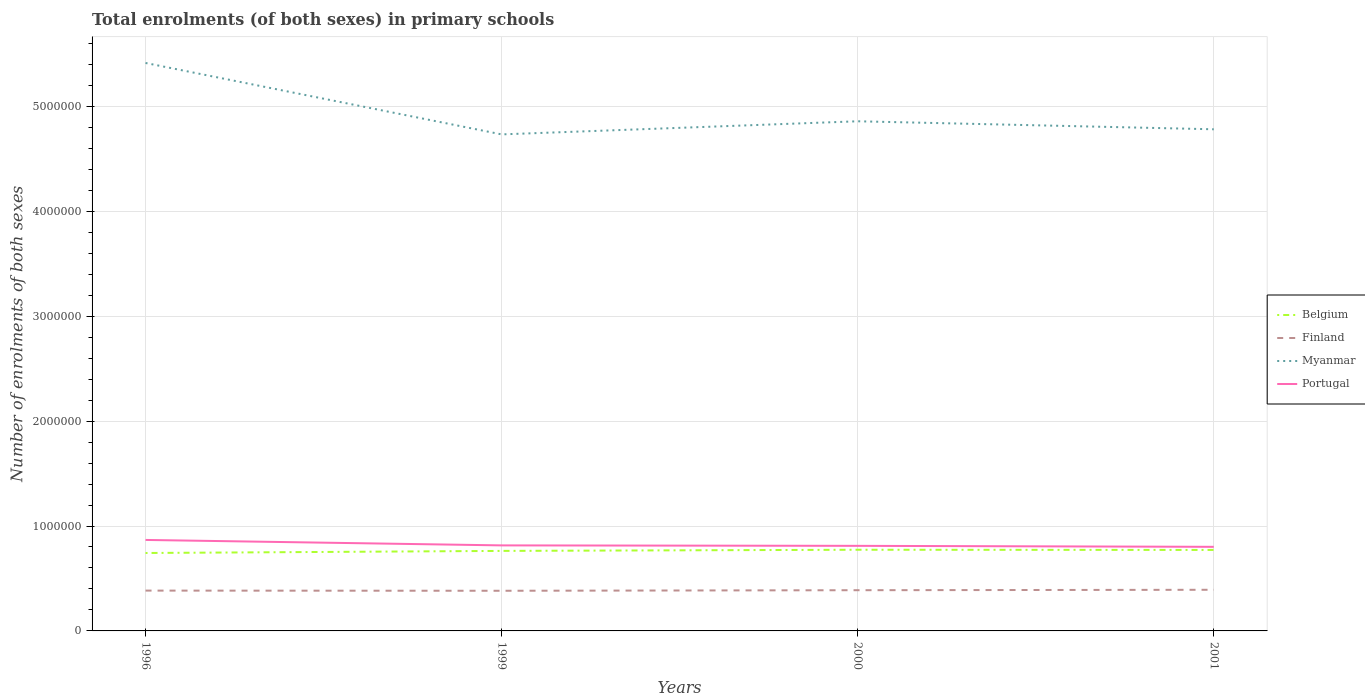How many different coloured lines are there?
Provide a short and direct response. 4. Does the line corresponding to Myanmar intersect with the line corresponding to Finland?
Your answer should be compact. No. Across all years, what is the maximum number of enrolments in primary schools in Portugal?
Ensure brevity in your answer.  8.02e+05. In which year was the number of enrolments in primary schools in Myanmar maximum?
Ensure brevity in your answer.  1999. What is the total number of enrolments in primary schools in Myanmar in the graph?
Give a very brief answer. 6.32e+05. What is the difference between the highest and the second highest number of enrolments in primary schools in Portugal?
Make the answer very short. 6.57e+04. What is the difference between the highest and the lowest number of enrolments in primary schools in Myanmar?
Keep it short and to the point. 1. Is the number of enrolments in primary schools in Finland strictly greater than the number of enrolments in primary schools in Belgium over the years?
Your answer should be very brief. Yes. How many lines are there?
Your answer should be very brief. 4. How many years are there in the graph?
Ensure brevity in your answer.  4. What is the difference between two consecutive major ticks on the Y-axis?
Your answer should be very brief. 1.00e+06. How many legend labels are there?
Your answer should be compact. 4. What is the title of the graph?
Your response must be concise. Total enrolments (of both sexes) in primary schools. Does "Bermuda" appear as one of the legend labels in the graph?
Your answer should be very brief. No. What is the label or title of the X-axis?
Keep it short and to the point. Years. What is the label or title of the Y-axis?
Provide a succinct answer. Number of enrolments of both sexes. What is the Number of enrolments of both sexes in Belgium in 1996?
Provide a short and direct response. 7.43e+05. What is the Number of enrolments of both sexes of Finland in 1996?
Offer a terse response. 3.84e+05. What is the Number of enrolments of both sexes of Myanmar in 1996?
Your response must be concise. 5.41e+06. What is the Number of enrolments of both sexes of Portugal in 1996?
Offer a terse response. 8.67e+05. What is the Number of enrolments of both sexes in Belgium in 1999?
Your answer should be very brief. 7.63e+05. What is the Number of enrolments of both sexes in Finland in 1999?
Ensure brevity in your answer.  3.83e+05. What is the Number of enrolments of both sexes of Myanmar in 1999?
Your response must be concise. 4.73e+06. What is the Number of enrolments of both sexes of Portugal in 1999?
Provide a succinct answer. 8.15e+05. What is the Number of enrolments of both sexes of Belgium in 2000?
Make the answer very short. 7.74e+05. What is the Number of enrolments of both sexes of Finland in 2000?
Your response must be concise. 3.88e+05. What is the Number of enrolments of both sexes in Myanmar in 2000?
Offer a terse response. 4.86e+06. What is the Number of enrolments of both sexes in Portugal in 2000?
Ensure brevity in your answer.  8.11e+05. What is the Number of enrolments of both sexes in Belgium in 2001?
Provide a short and direct response. 7.72e+05. What is the Number of enrolments of both sexes in Finland in 2001?
Offer a terse response. 3.92e+05. What is the Number of enrolments of both sexes of Myanmar in 2001?
Your response must be concise. 4.78e+06. What is the Number of enrolments of both sexes in Portugal in 2001?
Your answer should be very brief. 8.02e+05. Across all years, what is the maximum Number of enrolments of both sexes of Belgium?
Keep it short and to the point. 7.74e+05. Across all years, what is the maximum Number of enrolments of both sexes of Finland?
Provide a succinct answer. 3.92e+05. Across all years, what is the maximum Number of enrolments of both sexes of Myanmar?
Provide a short and direct response. 5.41e+06. Across all years, what is the maximum Number of enrolments of both sexes of Portugal?
Offer a terse response. 8.67e+05. Across all years, what is the minimum Number of enrolments of both sexes in Belgium?
Your answer should be very brief. 7.43e+05. Across all years, what is the minimum Number of enrolments of both sexes in Finland?
Your response must be concise. 3.83e+05. Across all years, what is the minimum Number of enrolments of both sexes of Myanmar?
Give a very brief answer. 4.73e+06. Across all years, what is the minimum Number of enrolments of both sexes in Portugal?
Your answer should be compact. 8.02e+05. What is the total Number of enrolments of both sexes of Belgium in the graph?
Your answer should be compact. 3.05e+06. What is the total Number of enrolments of both sexes in Finland in the graph?
Provide a succinct answer. 1.55e+06. What is the total Number of enrolments of both sexes of Myanmar in the graph?
Keep it short and to the point. 1.98e+07. What is the total Number of enrolments of both sexes of Portugal in the graph?
Make the answer very short. 3.30e+06. What is the difference between the Number of enrolments of both sexes of Belgium in 1996 and that in 1999?
Your response must be concise. -1.99e+04. What is the difference between the Number of enrolments of both sexes of Finland in 1996 and that in 1999?
Provide a short and direct response. 1623. What is the difference between the Number of enrolments of both sexes in Myanmar in 1996 and that in 1999?
Offer a very short reply. 6.81e+05. What is the difference between the Number of enrolments of both sexes in Portugal in 1996 and that in 1999?
Provide a succinct answer. 5.20e+04. What is the difference between the Number of enrolments of both sexes in Belgium in 1996 and that in 2000?
Your response must be concise. -3.09e+04. What is the difference between the Number of enrolments of both sexes of Finland in 1996 and that in 2000?
Provide a succinct answer. -3694. What is the difference between the Number of enrolments of both sexes in Myanmar in 1996 and that in 2000?
Keep it short and to the point. 5.56e+05. What is the difference between the Number of enrolments of both sexes in Portugal in 1996 and that in 2000?
Offer a terse response. 5.63e+04. What is the difference between the Number of enrolments of both sexes in Belgium in 1996 and that in 2001?
Offer a very short reply. -2.91e+04. What is the difference between the Number of enrolments of both sexes of Finland in 1996 and that in 2001?
Your answer should be compact. -7781. What is the difference between the Number of enrolments of both sexes in Myanmar in 1996 and that in 2001?
Ensure brevity in your answer.  6.32e+05. What is the difference between the Number of enrolments of both sexes in Portugal in 1996 and that in 2001?
Provide a succinct answer. 6.57e+04. What is the difference between the Number of enrolments of both sexes in Belgium in 1999 and that in 2000?
Offer a terse response. -1.10e+04. What is the difference between the Number of enrolments of both sexes in Finland in 1999 and that in 2000?
Your answer should be very brief. -5317. What is the difference between the Number of enrolments of both sexes in Myanmar in 1999 and that in 2000?
Offer a terse response. -1.25e+05. What is the difference between the Number of enrolments of both sexes in Portugal in 1999 and that in 2000?
Provide a short and direct response. 4235. What is the difference between the Number of enrolments of both sexes of Belgium in 1999 and that in 2001?
Offer a very short reply. -9155. What is the difference between the Number of enrolments of both sexes in Finland in 1999 and that in 2001?
Your answer should be compact. -9404. What is the difference between the Number of enrolments of both sexes of Myanmar in 1999 and that in 2001?
Offer a terse response. -4.86e+04. What is the difference between the Number of enrolments of both sexes in Portugal in 1999 and that in 2001?
Your answer should be very brief. 1.37e+04. What is the difference between the Number of enrolments of both sexes in Belgium in 2000 and that in 2001?
Provide a short and direct response. 1853. What is the difference between the Number of enrolments of both sexes of Finland in 2000 and that in 2001?
Your response must be concise. -4087. What is the difference between the Number of enrolments of both sexes in Myanmar in 2000 and that in 2001?
Keep it short and to the point. 7.64e+04. What is the difference between the Number of enrolments of both sexes in Portugal in 2000 and that in 2001?
Your response must be concise. 9451. What is the difference between the Number of enrolments of both sexes in Belgium in 1996 and the Number of enrolments of both sexes in Finland in 1999?
Keep it short and to the point. 3.60e+05. What is the difference between the Number of enrolments of both sexes in Belgium in 1996 and the Number of enrolments of both sexes in Myanmar in 1999?
Offer a terse response. -3.99e+06. What is the difference between the Number of enrolments of both sexes in Belgium in 1996 and the Number of enrolments of both sexes in Portugal in 1999?
Offer a terse response. -7.24e+04. What is the difference between the Number of enrolments of both sexes in Finland in 1996 and the Number of enrolments of both sexes in Myanmar in 1999?
Give a very brief answer. -4.35e+06. What is the difference between the Number of enrolments of both sexes in Finland in 1996 and the Number of enrolments of both sexes in Portugal in 1999?
Give a very brief answer. -4.31e+05. What is the difference between the Number of enrolments of both sexes in Myanmar in 1996 and the Number of enrolments of both sexes in Portugal in 1999?
Make the answer very short. 4.60e+06. What is the difference between the Number of enrolments of both sexes in Belgium in 1996 and the Number of enrolments of both sexes in Finland in 2000?
Provide a succinct answer. 3.55e+05. What is the difference between the Number of enrolments of both sexes of Belgium in 1996 and the Number of enrolments of both sexes of Myanmar in 2000?
Your answer should be compact. -4.12e+06. What is the difference between the Number of enrolments of both sexes in Belgium in 1996 and the Number of enrolments of both sexes in Portugal in 2000?
Your response must be concise. -6.82e+04. What is the difference between the Number of enrolments of both sexes in Finland in 1996 and the Number of enrolments of both sexes in Myanmar in 2000?
Ensure brevity in your answer.  -4.47e+06. What is the difference between the Number of enrolments of both sexes of Finland in 1996 and the Number of enrolments of both sexes of Portugal in 2000?
Give a very brief answer. -4.27e+05. What is the difference between the Number of enrolments of both sexes of Myanmar in 1996 and the Number of enrolments of both sexes of Portugal in 2000?
Ensure brevity in your answer.  4.60e+06. What is the difference between the Number of enrolments of both sexes of Belgium in 1996 and the Number of enrolments of both sexes of Finland in 2001?
Ensure brevity in your answer.  3.51e+05. What is the difference between the Number of enrolments of both sexes of Belgium in 1996 and the Number of enrolments of both sexes of Myanmar in 2001?
Keep it short and to the point. -4.04e+06. What is the difference between the Number of enrolments of both sexes in Belgium in 1996 and the Number of enrolments of both sexes in Portugal in 2001?
Give a very brief answer. -5.87e+04. What is the difference between the Number of enrolments of both sexes of Finland in 1996 and the Number of enrolments of both sexes of Myanmar in 2001?
Your answer should be compact. -4.40e+06. What is the difference between the Number of enrolments of both sexes of Finland in 1996 and the Number of enrolments of both sexes of Portugal in 2001?
Provide a short and direct response. -4.17e+05. What is the difference between the Number of enrolments of both sexes of Myanmar in 1996 and the Number of enrolments of both sexes of Portugal in 2001?
Keep it short and to the point. 4.61e+06. What is the difference between the Number of enrolments of both sexes in Belgium in 1999 and the Number of enrolments of both sexes in Finland in 2000?
Give a very brief answer. 3.75e+05. What is the difference between the Number of enrolments of both sexes of Belgium in 1999 and the Number of enrolments of both sexes of Myanmar in 2000?
Your response must be concise. -4.10e+06. What is the difference between the Number of enrolments of both sexes in Belgium in 1999 and the Number of enrolments of both sexes in Portugal in 2000?
Your answer should be compact. -4.83e+04. What is the difference between the Number of enrolments of both sexes of Finland in 1999 and the Number of enrolments of both sexes of Myanmar in 2000?
Your response must be concise. -4.48e+06. What is the difference between the Number of enrolments of both sexes in Finland in 1999 and the Number of enrolments of both sexes in Portugal in 2000?
Make the answer very short. -4.28e+05. What is the difference between the Number of enrolments of both sexes in Myanmar in 1999 and the Number of enrolments of both sexes in Portugal in 2000?
Offer a terse response. 3.92e+06. What is the difference between the Number of enrolments of both sexes in Belgium in 1999 and the Number of enrolments of both sexes in Finland in 2001?
Provide a short and direct response. 3.71e+05. What is the difference between the Number of enrolments of both sexes of Belgium in 1999 and the Number of enrolments of both sexes of Myanmar in 2001?
Your answer should be very brief. -4.02e+06. What is the difference between the Number of enrolments of both sexes of Belgium in 1999 and the Number of enrolments of both sexes of Portugal in 2001?
Keep it short and to the point. -3.88e+04. What is the difference between the Number of enrolments of both sexes in Finland in 1999 and the Number of enrolments of both sexes in Myanmar in 2001?
Keep it short and to the point. -4.40e+06. What is the difference between the Number of enrolments of both sexes of Finland in 1999 and the Number of enrolments of both sexes of Portugal in 2001?
Provide a short and direct response. -4.19e+05. What is the difference between the Number of enrolments of both sexes of Myanmar in 1999 and the Number of enrolments of both sexes of Portugal in 2001?
Your response must be concise. 3.93e+06. What is the difference between the Number of enrolments of both sexes in Belgium in 2000 and the Number of enrolments of both sexes in Finland in 2001?
Your response must be concise. 3.82e+05. What is the difference between the Number of enrolments of both sexes in Belgium in 2000 and the Number of enrolments of both sexes in Myanmar in 2001?
Your answer should be compact. -4.01e+06. What is the difference between the Number of enrolments of both sexes of Belgium in 2000 and the Number of enrolments of both sexes of Portugal in 2001?
Provide a short and direct response. -2.78e+04. What is the difference between the Number of enrolments of both sexes in Finland in 2000 and the Number of enrolments of both sexes in Myanmar in 2001?
Ensure brevity in your answer.  -4.39e+06. What is the difference between the Number of enrolments of both sexes in Finland in 2000 and the Number of enrolments of both sexes in Portugal in 2001?
Your answer should be very brief. -4.13e+05. What is the difference between the Number of enrolments of both sexes in Myanmar in 2000 and the Number of enrolments of both sexes in Portugal in 2001?
Ensure brevity in your answer.  4.06e+06. What is the average Number of enrolments of both sexes of Belgium per year?
Your response must be concise. 7.63e+05. What is the average Number of enrolments of both sexes in Finland per year?
Give a very brief answer. 3.87e+05. What is the average Number of enrolments of both sexes in Myanmar per year?
Keep it short and to the point. 4.95e+06. What is the average Number of enrolments of both sexes in Portugal per year?
Keep it short and to the point. 8.24e+05. In the year 1996, what is the difference between the Number of enrolments of both sexes in Belgium and Number of enrolments of both sexes in Finland?
Your answer should be very brief. 3.58e+05. In the year 1996, what is the difference between the Number of enrolments of both sexes in Belgium and Number of enrolments of both sexes in Myanmar?
Offer a very short reply. -4.67e+06. In the year 1996, what is the difference between the Number of enrolments of both sexes in Belgium and Number of enrolments of both sexes in Portugal?
Ensure brevity in your answer.  -1.24e+05. In the year 1996, what is the difference between the Number of enrolments of both sexes in Finland and Number of enrolments of both sexes in Myanmar?
Ensure brevity in your answer.  -5.03e+06. In the year 1996, what is the difference between the Number of enrolments of both sexes in Finland and Number of enrolments of both sexes in Portugal?
Offer a terse response. -4.83e+05. In the year 1996, what is the difference between the Number of enrolments of both sexes of Myanmar and Number of enrolments of both sexes of Portugal?
Keep it short and to the point. 4.55e+06. In the year 1999, what is the difference between the Number of enrolments of both sexes in Belgium and Number of enrolments of both sexes in Finland?
Make the answer very short. 3.80e+05. In the year 1999, what is the difference between the Number of enrolments of both sexes in Belgium and Number of enrolments of both sexes in Myanmar?
Keep it short and to the point. -3.97e+06. In the year 1999, what is the difference between the Number of enrolments of both sexes in Belgium and Number of enrolments of both sexes in Portugal?
Keep it short and to the point. -5.25e+04. In the year 1999, what is the difference between the Number of enrolments of both sexes in Finland and Number of enrolments of both sexes in Myanmar?
Give a very brief answer. -4.35e+06. In the year 1999, what is the difference between the Number of enrolments of both sexes of Finland and Number of enrolments of both sexes of Portugal?
Your response must be concise. -4.32e+05. In the year 1999, what is the difference between the Number of enrolments of both sexes of Myanmar and Number of enrolments of both sexes of Portugal?
Ensure brevity in your answer.  3.92e+06. In the year 2000, what is the difference between the Number of enrolments of both sexes in Belgium and Number of enrolments of both sexes in Finland?
Make the answer very short. 3.86e+05. In the year 2000, what is the difference between the Number of enrolments of both sexes of Belgium and Number of enrolments of both sexes of Myanmar?
Your response must be concise. -4.08e+06. In the year 2000, what is the difference between the Number of enrolments of both sexes in Belgium and Number of enrolments of both sexes in Portugal?
Give a very brief answer. -3.73e+04. In the year 2000, what is the difference between the Number of enrolments of both sexes of Finland and Number of enrolments of both sexes of Myanmar?
Make the answer very short. -4.47e+06. In the year 2000, what is the difference between the Number of enrolments of both sexes in Finland and Number of enrolments of both sexes in Portugal?
Your response must be concise. -4.23e+05. In the year 2000, what is the difference between the Number of enrolments of both sexes of Myanmar and Number of enrolments of both sexes of Portugal?
Your answer should be compact. 4.05e+06. In the year 2001, what is the difference between the Number of enrolments of both sexes of Belgium and Number of enrolments of both sexes of Finland?
Ensure brevity in your answer.  3.80e+05. In the year 2001, what is the difference between the Number of enrolments of both sexes of Belgium and Number of enrolments of both sexes of Myanmar?
Provide a succinct answer. -4.01e+06. In the year 2001, what is the difference between the Number of enrolments of both sexes of Belgium and Number of enrolments of both sexes of Portugal?
Give a very brief answer. -2.97e+04. In the year 2001, what is the difference between the Number of enrolments of both sexes of Finland and Number of enrolments of both sexes of Myanmar?
Keep it short and to the point. -4.39e+06. In the year 2001, what is the difference between the Number of enrolments of both sexes in Finland and Number of enrolments of both sexes in Portugal?
Make the answer very short. -4.09e+05. In the year 2001, what is the difference between the Number of enrolments of both sexes of Myanmar and Number of enrolments of both sexes of Portugal?
Offer a terse response. 3.98e+06. What is the ratio of the Number of enrolments of both sexes of Belgium in 1996 to that in 1999?
Offer a very short reply. 0.97. What is the ratio of the Number of enrolments of both sexes in Myanmar in 1996 to that in 1999?
Keep it short and to the point. 1.14. What is the ratio of the Number of enrolments of both sexes in Portugal in 1996 to that in 1999?
Your answer should be very brief. 1.06. What is the ratio of the Number of enrolments of both sexes of Finland in 1996 to that in 2000?
Your answer should be compact. 0.99. What is the ratio of the Number of enrolments of both sexes of Myanmar in 1996 to that in 2000?
Provide a short and direct response. 1.11. What is the ratio of the Number of enrolments of both sexes of Portugal in 1996 to that in 2000?
Provide a succinct answer. 1.07. What is the ratio of the Number of enrolments of both sexes in Belgium in 1996 to that in 2001?
Ensure brevity in your answer.  0.96. What is the ratio of the Number of enrolments of both sexes in Finland in 1996 to that in 2001?
Provide a succinct answer. 0.98. What is the ratio of the Number of enrolments of both sexes of Myanmar in 1996 to that in 2001?
Your answer should be compact. 1.13. What is the ratio of the Number of enrolments of both sexes of Portugal in 1996 to that in 2001?
Provide a short and direct response. 1.08. What is the ratio of the Number of enrolments of both sexes of Belgium in 1999 to that in 2000?
Your response must be concise. 0.99. What is the ratio of the Number of enrolments of both sexes of Finland in 1999 to that in 2000?
Offer a very short reply. 0.99. What is the ratio of the Number of enrolments of both sexes of Myanmar in 1999 to that in 2000?
Offer a terse response. 0.97. What is the ratio of the Number of enrolments of both sexes of Belgium in 1999 to that in 2001?
Offer a terse response. 0.99. What is the ratio of the Number of enrolments of both sexes of Portugal in 1999 to that in 2001?
Your answer should be very brief. 1.02. What is the ratio of the Number of enrolments of both sexes of Belgium in 2000 to that in 2001?
Provide a short and direct response. 1. What is the ratio of the Number of enrolments of both sexes in Portugal in 2000 to that in 2001?
Your answer should be very brief. 1.01. What is the difference between the highest and the second highest Number of enrolments of both sexes of Belgium?
Your answer should be very brief. 1853. What is the difference between the highest and the second highest Number of enrolments of both sexes of Finland?
Your response must be concise. 4087. What is the difference between the highest and the second highest Number of enrolments of both sexes in Myanmar?
Keep it short and to the point. 5.56e+05. What is the difference between the highest and the second highest Number of enrolments of both sexes in Portugal?
Provide a short and direct response. 5.20e+04. What is the difference between the highest and the lowest Number of enrolments of both sexes of Belgium?
Provide a short and direct response. 3.09e+04. What is the difference between the highest and the lowest Number of enrolments of both sexes of Finland?
Ensure brevity in your answer.  9404. What is the difference between the highest and the lowest Number of enrolments of both sexes of Myanmar?
Ensure brevity in your answer.  6.81e+05. What is the difference between the highest and the lowest Number of enrolments of both sexes in Portugal?
Provide a succinct answer. 6.57e+04. 